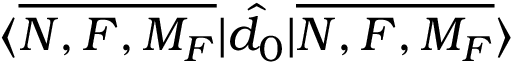Convert formula to latex. <formula><loc_0><loc_0><loc_500><loc_500>{ \langle \overline { { N , F , M _ { F } } } | \hat { d } _ { 0 } | \overline { { N , F , M _ { F } } } \rangle }</formula> 